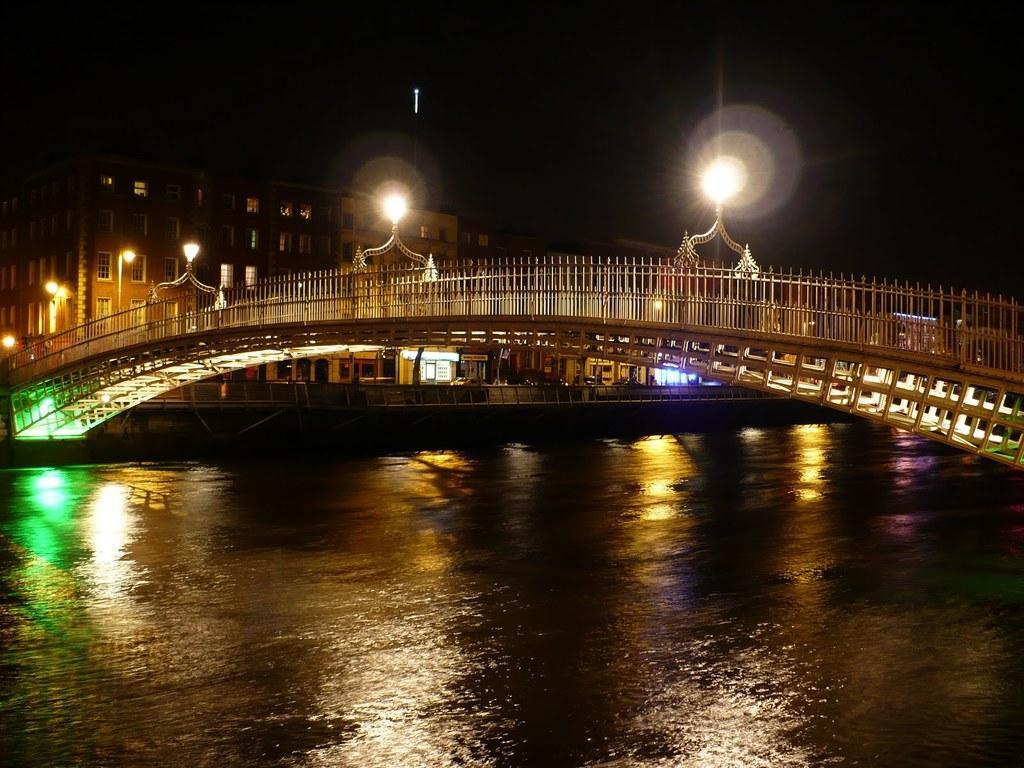Describe this image in one or two sentences. In the image we can see there is water and on the top there is a bridge. There are lightings on the bridge and behind there are buildings. 